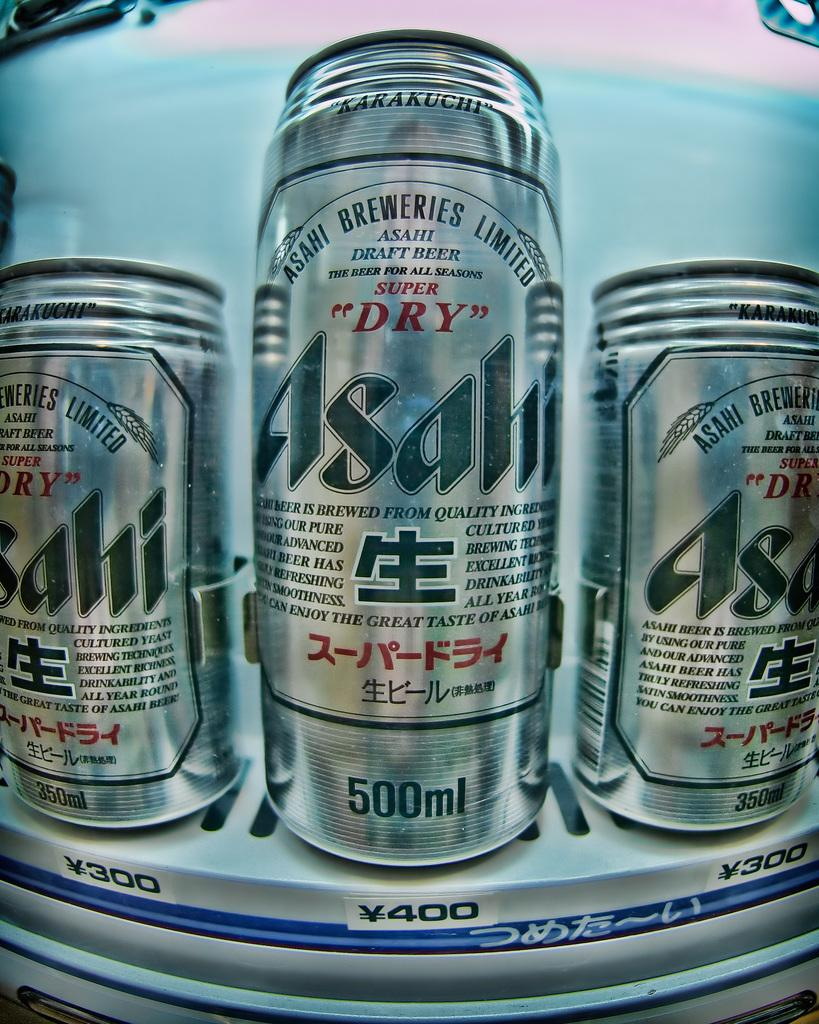Provide a one-sentence caption for the provided image. Three cans in various sizes of Asali Super Dry inside a foreign vending machine. 